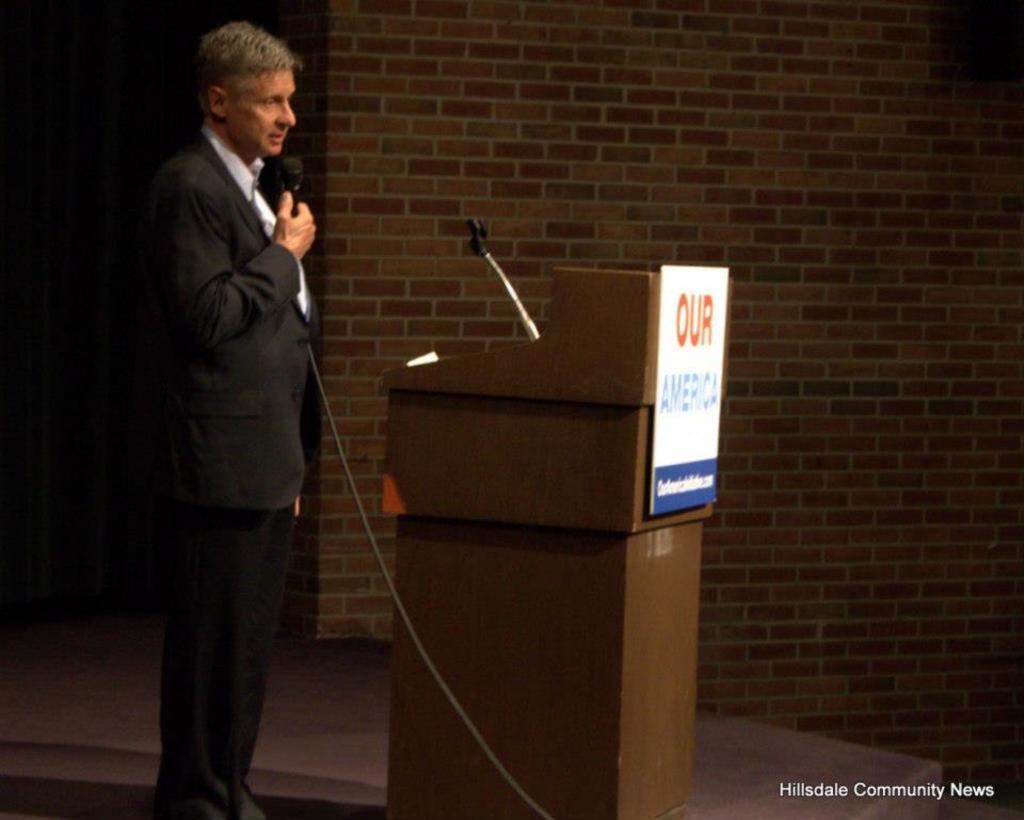Who's country is this?
Keep it short and to the point. America. What is in red on the podium sign?
Make the answer very short. Our. 